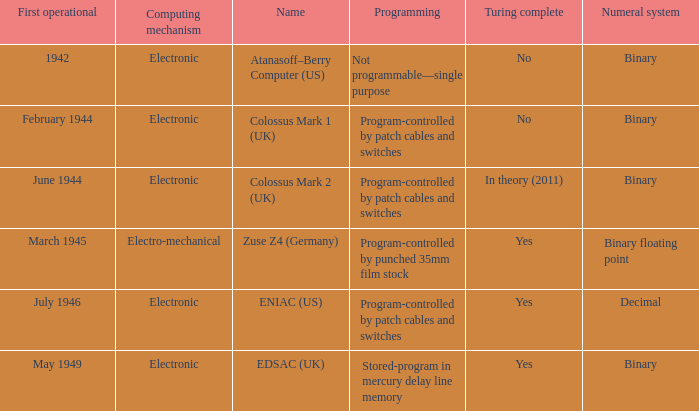What's the turing complete with name being atanasoff–berry computer (us) No. Could you help me parse every detail presented in this table? {'header': ['First operational', 'Computing mechanism', 'Name', 'Programming', 'Turing complete', 'Numeral system'], 'rows': [['1942', 'Electronic', 'Atanasoff–Berry Computer (US)', 'Not programmable—single purpose', 'No', 'Binary'], ['February 1944', 'Electronic', 'Colossus Mark 1 (UK)', 'Program-controlled by patch cables and switches', 'No', 'Binary'], ['June 1944', 'Electronic', 'Colossus Mark 2 (UK)', 'Program-controlled by patch cables and switches', 'In theory (2011)', 'Binary'], ['March 1945', 'Electro-mechanical', 'Zuse Z4 (Germany)', 'Program-controlled by punched 35mm film stock', 'Yes', 'Binary floating point'], ['July 1946', 'Electronic', 'ENIAC (US)', 'Program-controlled by patch cables and switches', 'Yes', 'Decimal'], ['May 1949', 'Electronic', 'EDSAC (UK)', 'Stored-program in mercury delay line memory', 'Yes', 'Binary']]} 